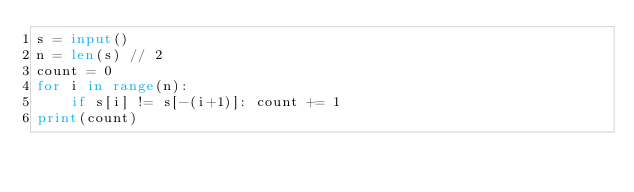<code> <loc_0><loc_0><loc_500><loc_500><_Python_>s = input()
n = len(s) // 2
count = 0
for i in range(n):
    if s[i] != s[-(i+1)]: count += 1
print(count)
</code> 